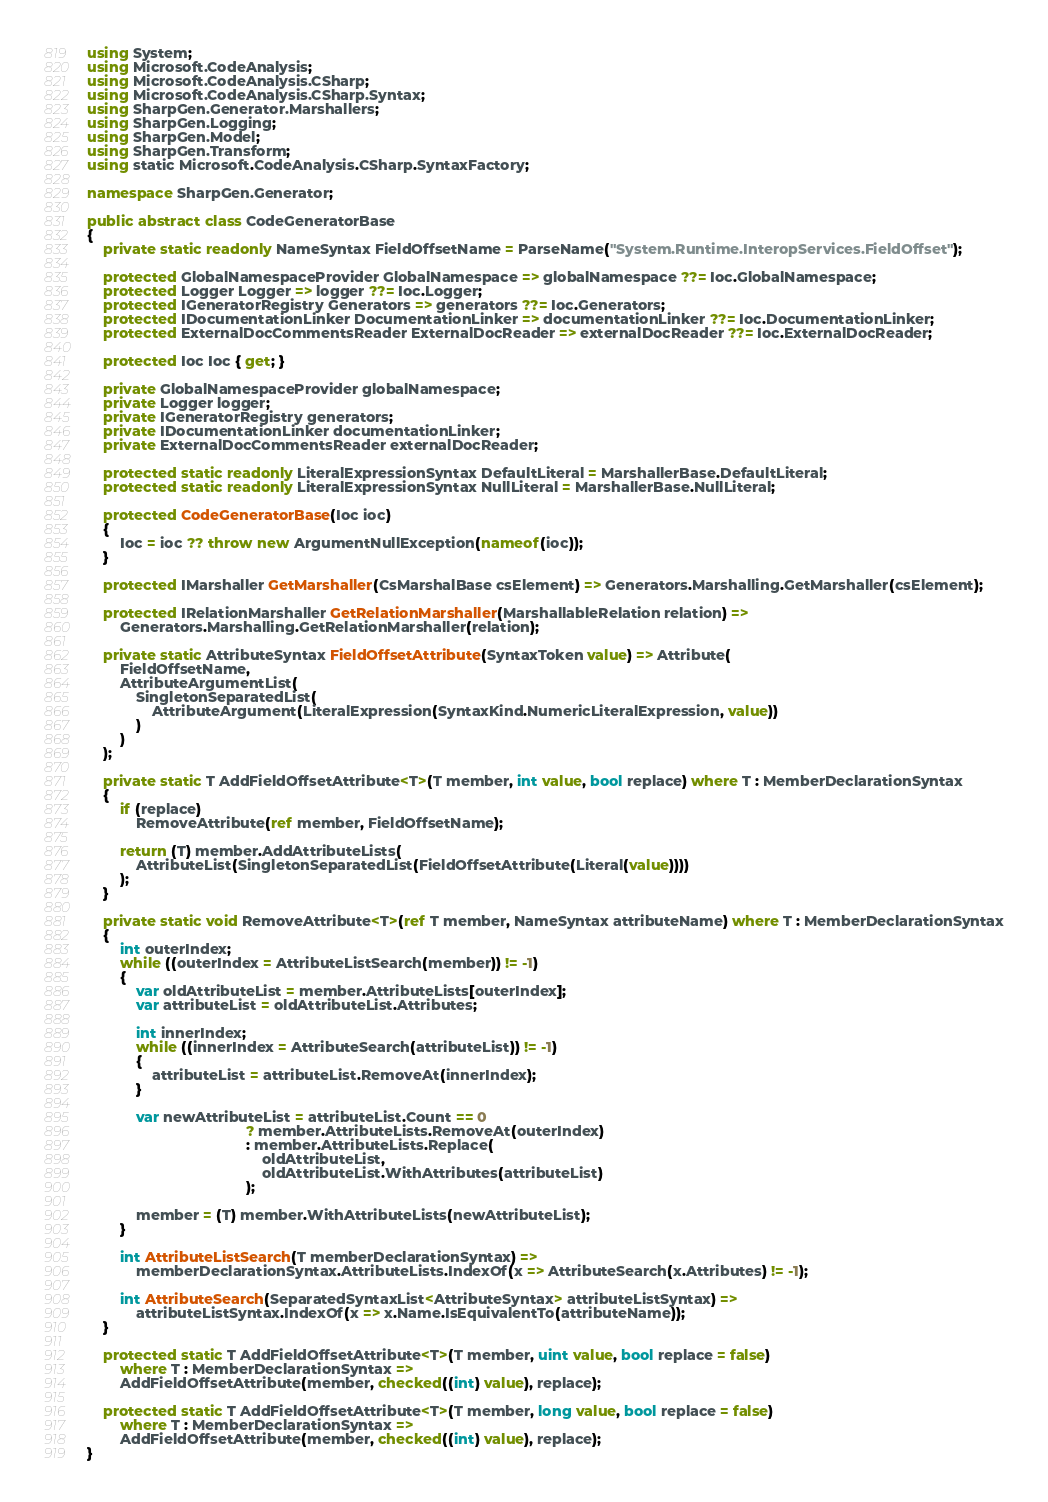<code> <loc_0><loc_0><loc_500><loc_500><_C#_>using System;
using Microsoft.CodeAnalysis;
using Microsoft.CodeAnalysis.CSharp;
using Microsoft.CodeAnalysis.CSharp.Syntax;
using SharpGen.Generator.Marshallers;
using SharpGen.Logging;
using SharpGen.Model;
using SharpGen.Transform;
using static Microsoft.CodeAnalysis.CSharp.SyntaxFactory;

namespace SharpGen.Generator;

public abstract class CodeGeneratorBase
{
    private static readonly NameSyntax FieldOffsetName = ParseName("System.Runtime.InteropServices.FieldOffset");

    protected GlobalNamespaceProvider GlobalNamespace => globalNamespace ??= Ioc.GlobalNamespace;
    protected Logger Logger => logger ??= Ioc.Logger;
    protected IGeneratorRegistry Generators => generators ??= Ioc.Generators;
    protected IDocumentationLinker DocumentationLinker => documentationLinker ??= Ioc.DocumentationLinker;
    protected ExternalDocCommentsReader ExternalDocReader => externalDocReader ??= Ioc.ExternalDocReader;

    protected Ioc Ioc { get; }

    private GlobalNamespaceProvider globalNamespace;
    private Logger logger;
    private IGeneratorRegistry generators;
    private IDocumentationLinker documentationLinker;
    private ExternalDocCommentsReader externalDocReader;

    protected static readonly LiteralExpressionSyntax DefaultLiteral = MarshallerBase.DefaultLiteral;
    protected static readonly LiteralExpressionSyntax NullLiteral = MarshallerBase.NullLiteral;

    protected CodeGeneratorBase(Ioc ioc)
    {
        Ioc = ioc ?? throw new ArgumentNullException(nameof(ioc));
    }

    protected IMarshaller GetMarshaller(CsMarshalBase csElement) => Generators.Marshalling.GetMarshaller(csElement);

    protected IRelationMarshaller GetRelationMarshaller(MarshallableRelation relation) =>
        Generators.Marshalling.GetRelationMarshaller(relation);

    private static AttributeSyntax FieldOffsetAttribute(SyntaxToken value) => Attribute(
        FieldOffsetName,
        AttributeArgumentList(
            SingletonSeparatedList(
                AttributeArgument(LiteralExpression(SyntaxKind.NumericLiteralExpression, value))
            )
        )
    );

    private static T AddFieldOffsetAttribute<T>(T member, int value, bool replace) where T : MemberDeclarationSyntax
    {
        if (replace)
            RemoveAttribute(ref member, FieldOffsetName);

        return (T) member.AddAttributeLists(
            AttributeList(SingletonSeparatedList(FieldOffsetAttribute(Literal(value))))
        );
    }

    private static void RemoveAttribute<T>(ref T member, NameSyntax attributeName) where T : MemberDeclarationSyntax
    {
        int outerIndex;
        while ((outerIndex = AttributeListSearch(member)) != -1)
        {
            var oldAttributeList = member.AttributeLists[outerIndex];
            var attributeList = oldAttributeList.Attributes;

            int innerIndex;
            while ((innerIndex = AttributeSearch(attributeList)) != -1)
            {
                attributeList = attributeList.RemoveAt(innerIndex);
            }

            var newAttributeList = attributeList.Count == 0
                                       ? member.AttributeLists.RemoveAt(outerIndex)
                                       : member.AttributeLists.Replace(
                                           oldAttributeList,
                                           oldAttributeList.WithAttributes(attributeList)
                                       );

            member = (T) member.WithAttributeLists(newAttributeList);
        }

        int AttributeListSearch(T memberDeclarationSyntax) =>
            memberDeclarationSyntax.AttributeLists.IndexOf(x => AttributeSearch(x.Attributes) != -1);

        int AttributeSearch(SeparatedSyntaxList<AttributeSyntax> attributeListSyntax) =>
            attributeListSyntax.IndexOf(x => x.Name.IsEquivalentTo(attributeName));
    }

    protected static T AddFieldOffsetAttribute<T>(T member, uint value, bool replace = false)
        where T : MemberDeclarationSyntax =>
        AddFieldOffsetAttribute(member, checked((int) value), replace);

    protected static T AddFieldOffsetAttribute<T>(T member, long value, bool replace = false)
        where T : MemberDeclarationSyntax =>
        AddFieldOffsetAttribute(member, checked((int) value), replace);
}</code> 